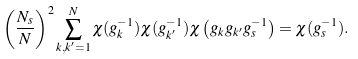<formula> <loc_0><loc_0><loc_500><loc_500>\left ( \frac { N _ { s } } { N } \right ) ^ { 2 } \sum _ { k , k ^ { \prime } = 1 } ^ { N } \chi ( g _ { k } ^ { - 1 } ) \chi ( g _ { k ^ { \prime } } ^ { - 1 } ) \chi \left ( g _ { k } g _ { k ^ { \prime } } g _ { s } ^ { - 1 } \right ) = \chi ( g _ { s } ^ { - 1 } ) .</formula> 